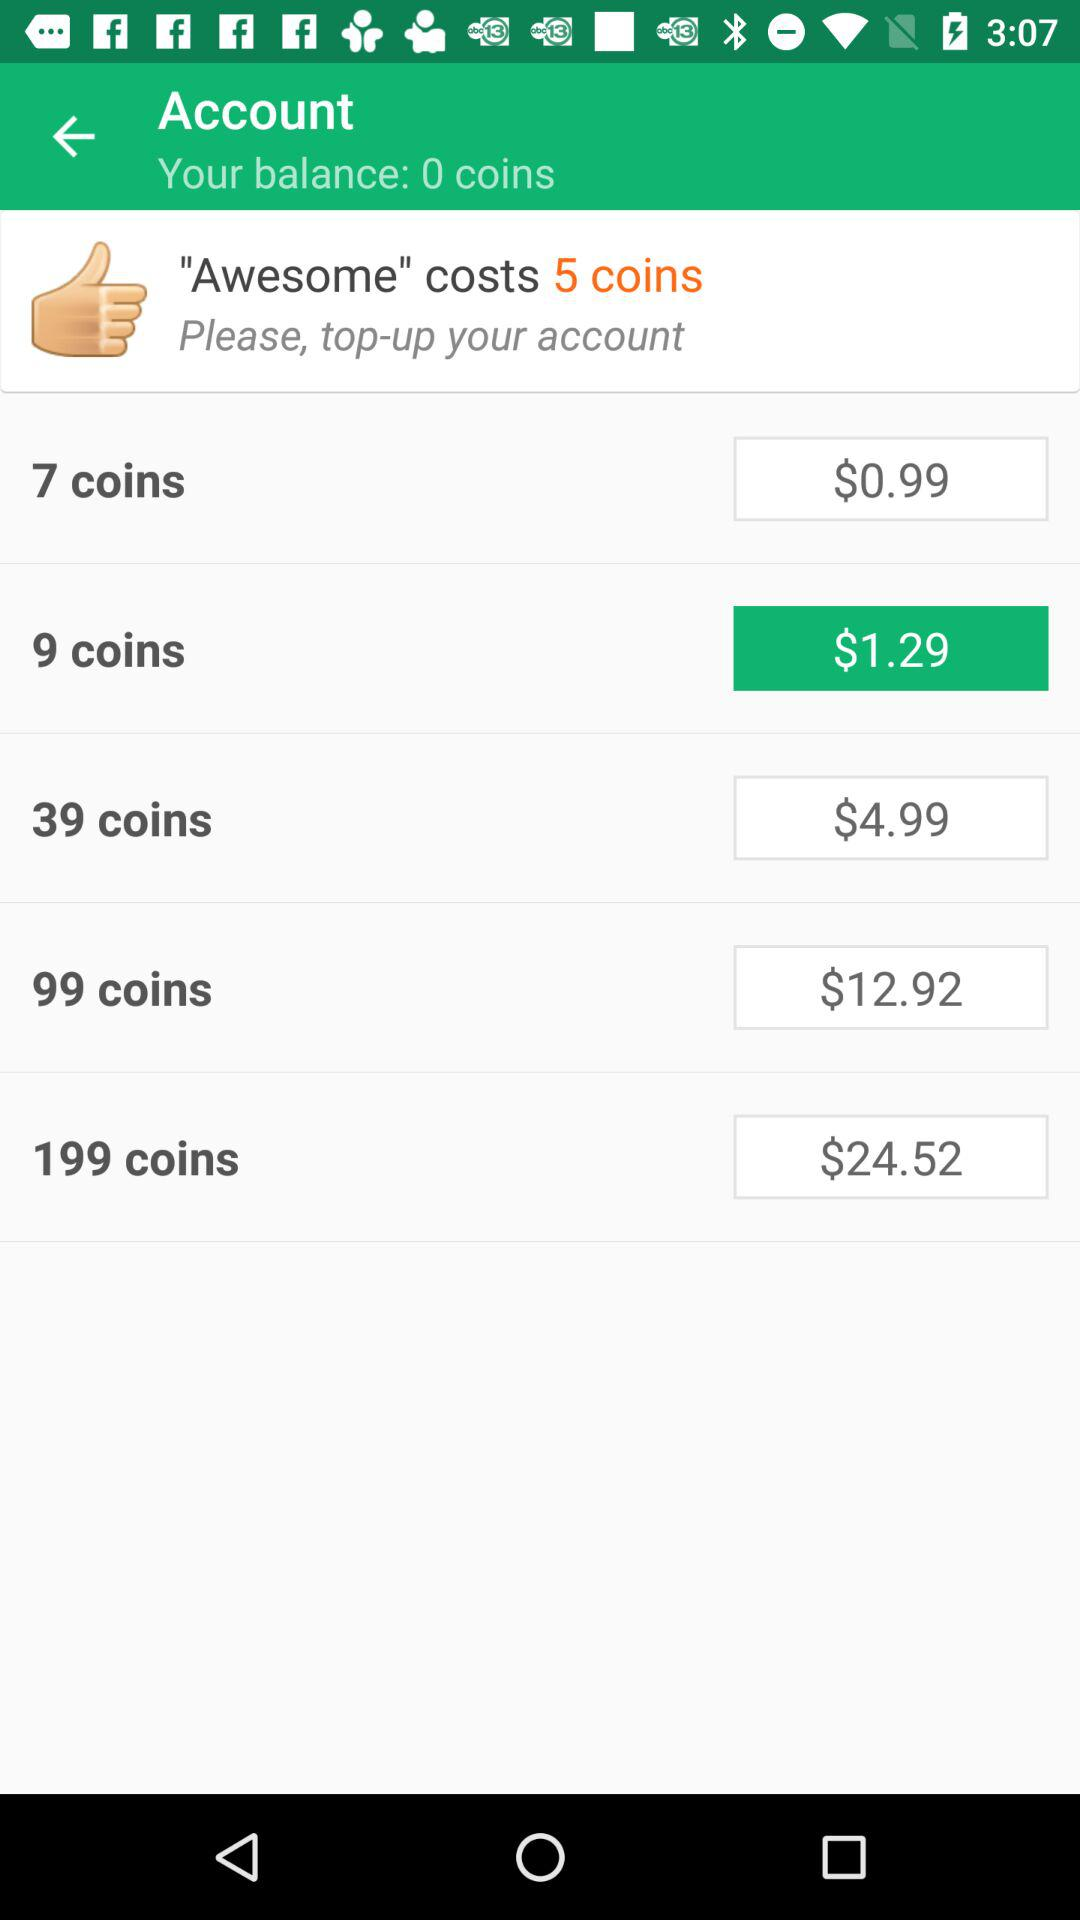How many coins are required to purchase the most expensive item?
Answer the question using a single word or phrase. 199 